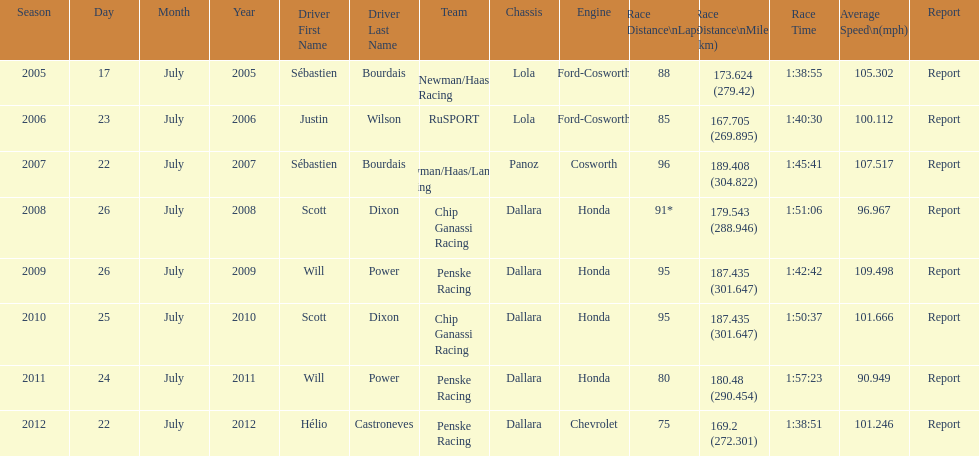What is the least amount of laps completed? 75. Can you give me this table as a dict? {'header': ['Season', 'Day', 'Month', 'Year', 'Driver First Name', 'Driver Last Name', 'Team', 'Chassis', 'Engine', 'Race Distance\\nLaps', 'Race Distance\\nMiles (km)', 'Race Time', 'Average Speed\\n(mph)', 'Report'], 'rows': [['2005', '17', 'July', '2005', 'Sébastien', 'Bourdais', 'Newman/Haas Racing', 'Lola', 'Ford-Cosworth', '88', '173.624 (279.42)', '1:38:55', '105.302', 'Report'], ['2006', '23', 'July', '2006', 'Justin', 'Wilson', 'RuSPORT', 'Lola', 'Ford-Cosworth', '85', '167.705 (269.895)', '1:40:30', '100.112', 'Report'], ['2007', '22', 'July', '2007', 'Sébastien', 'Bourdais', 'Newman/Haas/Lanigan Racing', 'Panoz', 'Cosworth', '96', '189.408 (304.822)', '1:45:41', '107.517', 'Report'], ['2008', '26', 'July', '2008', 'Scott', 'Dixon', 'Chip Ganassi Racing', 'Dallara', 'Honda', '91*', '179.543 (288.946)', '1:51:06', '96.967', 'Report'], ['2009', '26', 'July', '2009', 'Will', 'Power', 'Penske Racing', 'Dallara', 'Honda', '95', '187.435 (301.647)', '1:42:42', '109.498', 'Report'], ['2010', '25', 'July', '2010', 'Scott', 'Dixon', 'Chip Ganassi Racing', 'Dallara', 'Honda', '95', '187.435 (301.647)', '1:50:37', '101.666', 'Report'], ['2011', '24', 'July', '2011', 'Will', 'Power', 'Penske Racing', 'Dallara', 'Honda', '80', '180.48 (290.454)', '1:57:23', '90.949', 'Report'], ['2012', '22', 'July', '2012', 'Hélio', 'Castroneves', 'Penske Racing', 'Dallara', 'Chevrolet', '75', '169.2 (272.301)', '1:38:51', '101.246', 'Report']]} 